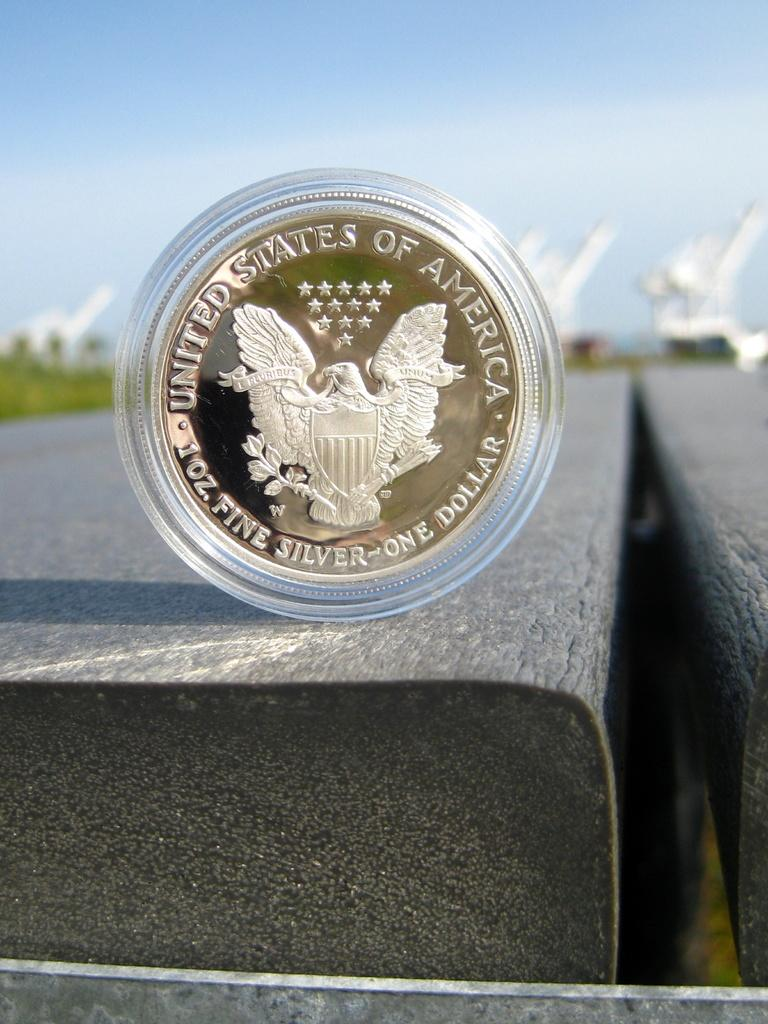<image>
Offer a succinct explanation of the picture presented. a golden coin in plastic with words that say 'united states of america' on it 